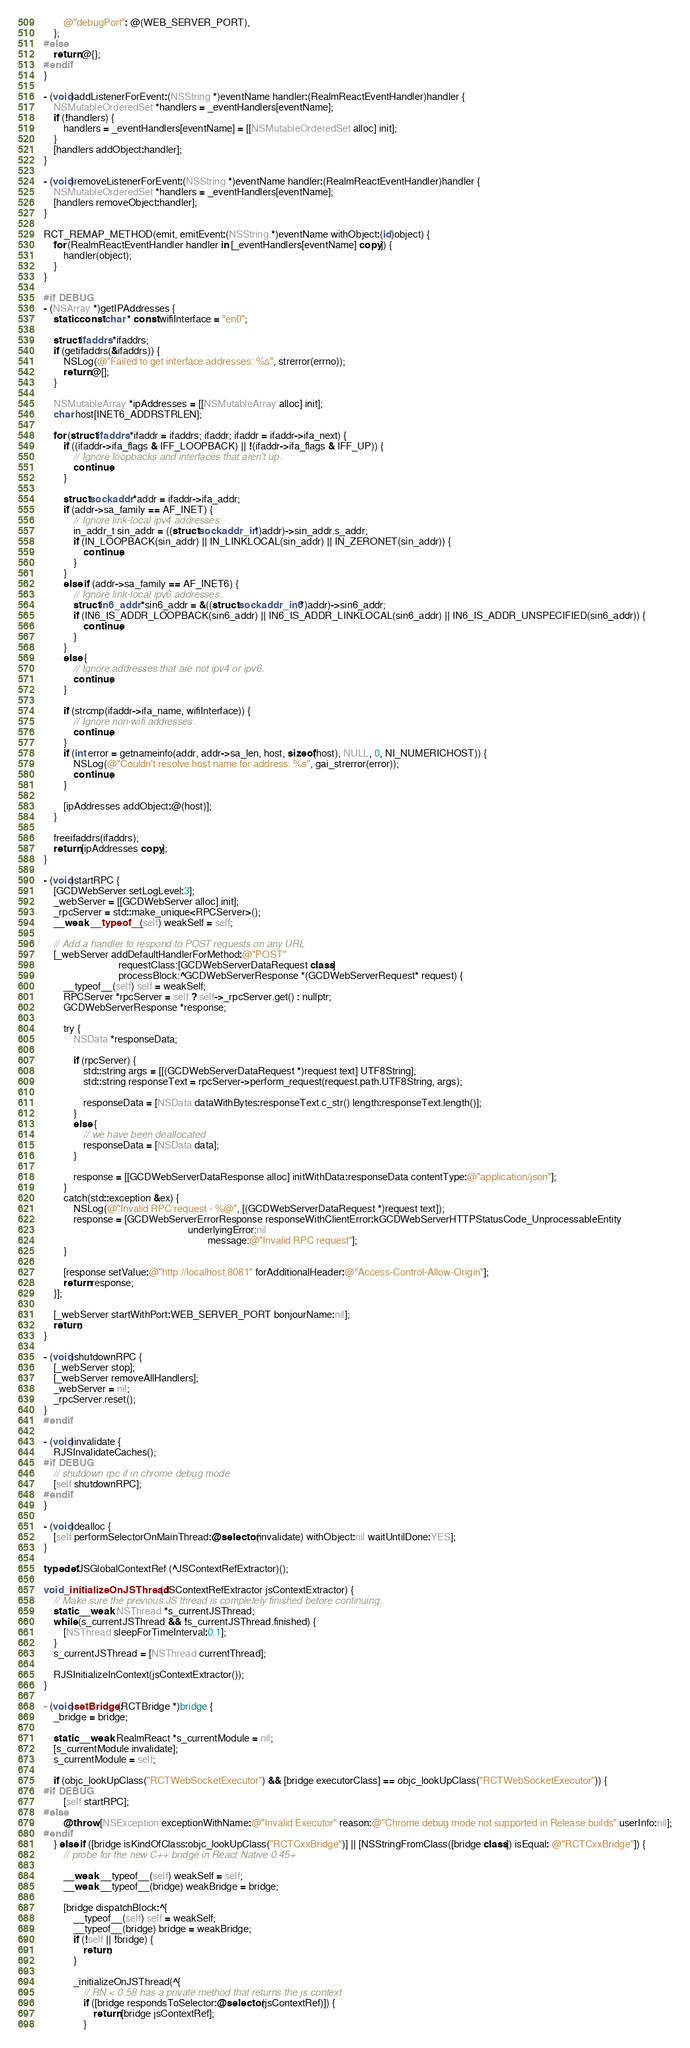<code> <loc_0><loc_0><loc_500><loc_500><_ObjectiveC_>        @"debugPort": @(WEB_SERVER_PORT),
    };
#else
    return @{};
#endif
}

- (void)addListenerForEvent:(NSString *)eventName handler:(RealmReactEventHandler)handler {
    NSMutableOrderedSet *handlers = _eventHandlers[eventName];
    if (!handlers) {
        handlers = _eventHandlers[eventName] = [[NSMutableOrderedSet alloc] init];
    }
    [handlers addObject:handler];
}

- (void)removeListenerForEvent:(NSString *)eventName handler:(RealmReactEventHandler)handler {
    NSMutableOrderedSet *handlers = _eventHandlers[eventName];
    [handlers removeObject:handler];
}

RCT_REMAP_METHOD(emit, emitEvent:(NSString *)eventName withObject:(id)object) {
    for (RealmReactEventHandler handler in [_eventHandlers[eventName] copy]) {
        handler(object);
    }
}

#if DEBUG
- (NSArray *)getIPAddresses {
    static const char * const wifiInterface = "en0";

    struct ifaddrs *ifaddrs;
    if (getifaddrs(&ifaddrs)) {
        NSLog(@"Failed to get interface addresses: %s", strerror(errno));
        return @[];
    }

    NSMutableArray *ipAddresses = [[NSMutableArray alloc] init];
    char host[INET6_ADDRSTRLEN];

    for (struct ifaddrs *ifaddr = ifaddrs; ifaddr; ifaddr = ifaddr->ifa_next) {
        if ((ifaddr->ifa_flags & IFF_LOOPBACK) || !(ifaddr->ifa_flags & IFF_UP)) {
            // Ignore loopbacks and interfaces that aren't up.
            continue;
        }

        struct sockaddr *addr = ifaddr->ifa_addr;
        if (addr->sa_family == AF_INET) {
            // Ignore link-local ipv4 addresses.
            in_addr_t sin_addr = ((struct sockaddr_in *)addr)->sin_addr.s_addr;
            if (IN_LOOPBACK(sin_addr) || IN_LINKLOCAL(sin_addr) || IN_ZERONET(sin_addr)) {
                continue;
            }
        }
        else if (addr->sa_family == AF_INET6) {
            // Ignore link-local ipv6 addresses.
            struct in6_addr *sin6_addr = &((struct sockaddr_in6 *)addr)->sin6_addr;
            if (IN6_IS_ADDR_LOOPBACK(sin6_addr) || IN6_IS_ADDR_LINKLOCAL(sin6_addr) || IN6_IS_ADDR_UNSPECIFIED(sin6_addr)) {
                continue;
            }
        }
        else {
            // Ignore addresses that are not ipv4 or ipv6.
            continue;
        }

        if (strcmp(ifaddr->ifa_name, wifiInterface)) {
            // Ignore non-wifi addresses.
            continue;
        }
        if (int error = getnameinfo(addr, addr->sa_len, host, sizeof(host), NULL, 0, NI_NUMERICHOST)) {
            NSLog(@"Couldn't resolve host name for address: %s", gai_strerror(error));
            continue;
        }

        [ipAddresses addObject:@(host)];
    }

    freeifaddrs(ifaddrs);
    return [ipAddresses copy];
}

- (void)startRPC {
    [GCDWebServer setLogLevel:3];
    _webServer = [[GCDWebServer alloc] init];
    _rpcServer = std::make_unique<RPCServer>();
    __weak __typeof__(self) weakSelf = self;

    // Add a handler to respond to POST requests on any URL
    [_webServer addDefaultHandlerForMethod:@"POST"
                              requestClass:[GCDWebServerDataRequest class]
                              processBlock:^GCDWebServerResponse *(GCDWebServerRequest* request) {
        __typeof__(self) self = weakSelf;
        RPCServer *rpcServer = self ? self->_rpcServer.get() : nullptr;
        GCDWebServerResponse *response;

        try {
            NSData *responseData;

            if (rpcServer) {
                std::string args = [[(GCDWebServerDataRequest *)request text] UTF8String];
                std::string responseText = rpcServer->perform_request(request.path.UTF8String, args);

                responseData = [NSData dataWithBytes:responseText.c_str() length:responseText.length()];
            }
            else {
                // we have been deallocated
                responseData = [NSData data];
            }

            response = [[GCDWebServerDataResponse alloc] initWithData:responseData contentType:@"application/json"];
        }
        catch(std::exception &ex) {
            NSLog(@"Invalid RPC request - %@", [(GCDWebServerDataRequest *)request text]);
            response = [GCDWebServerErrorResponse responseWithClientError:kGCDWebServerHTTPStatusCode_UnprocessableEntity
                                                          underlyingError:nil
                                                                  message:@"Invalid RPC request"];
        }

        [response setValue:@"http://localhost:8081" forAdditionalHeader:@"Access-Control-Allow-Origin"];
        return response;
    }];

    [_webServer startWithPort:WEB_SERVER_PORT bonjourName:nil];
    return;
}

- (void)shutdownRPC {
    [_webServer stop];
    [_webServer removeAllHandlers];
    _webServer = nil;
    _rpcServer.reset();
}
#endif

- (void)invalidate {
    RJSInvalidateCaches();
#if DEBUG
    // shutdown rpc if in chrome debug mode
    [self shutdownRPC];
#endif
}

- (void)dealloc {
    [self performSelectorOnMainThread:@selector(invalidate) withObject:nil waitUntilDone:YES];
}

typedef JSGlobalContextRef (^JSContextRefExtractor)();

void _initializeOnJSThread(JSContextRefExtractor jsContextExtractor) {
    // Make sure the previous JS thread is completely finished before continuing.
    static __weak NSThread *s_currentJSThread;
    while (s_currentJSThread && !s_currentJSThread.finished) {
        [NSThread sleepForTimeInterval:0.1];
    }
    s_currentJSThread = [NSThread currentThread];

    RJSInitializeInContext(jsContextExtractor());
}

- (void)setBridge:(RCTBridge *)bridge {
    _bridge = bridge;

    static __weak RealmReact *s_currentModule = nil;
    [s_currentModule invalidate];
    s_currentModule = self;

    if (objc_lookUpClass("RCTWebSocketExecutor") && [bridge executorClass] == objc_lookUpClass("RCTWebSocketExecutor")) {
#if DEBUG
        [self startRPC];
#else
        @throw [NSException exceptionWithName:@"Invalid Executor" reason:@"Chrome debug mode not supported in Release builds" userInfo:nil];
#endif
    } else if ([bridge isKindOfClass:objc_lookUpClass("RCTCxxBridge")] || [NSStringFromClass([bridge class]) isEqual: @"RCTCxxBridge"]) {
        // probe for the new C++ bridge in React Native 0.45+

        __weak __typeof__(self) weakSelf = self;
        __weak __typeof__(bridge) weakBridge = bridge;

        [bridge dispatchBlock:^{
            __typeof__(self) self = weakSelf;
            __typeof__(bridge) bridge = weakBridge;
            if (!self || !bridge) {
                return;
            }

            _initializeOnJSThread(^{
                // RN < 0.58 has a private method that returns the js context
                if ([bridge respondsToSelector:@selector(jsContextRef)]) {
                    return [bridge jsContextRef];
                }</code> 